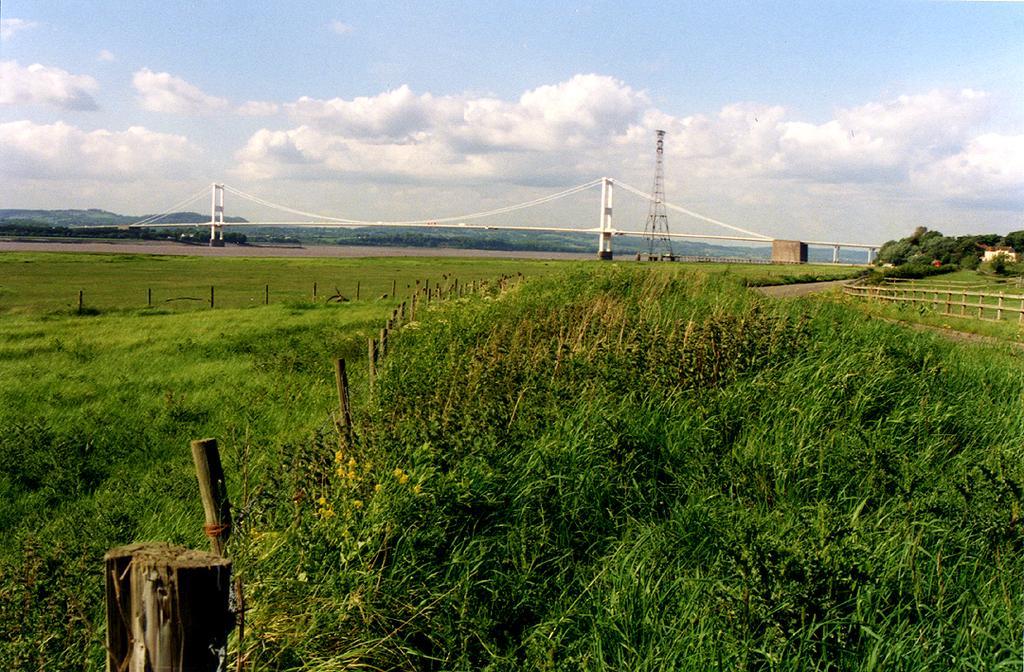Can you describe this image briefly? In this image I can see few plants. I can see a bridge. I can see a tower. I can see few trees. I can see clouds in the sky. 